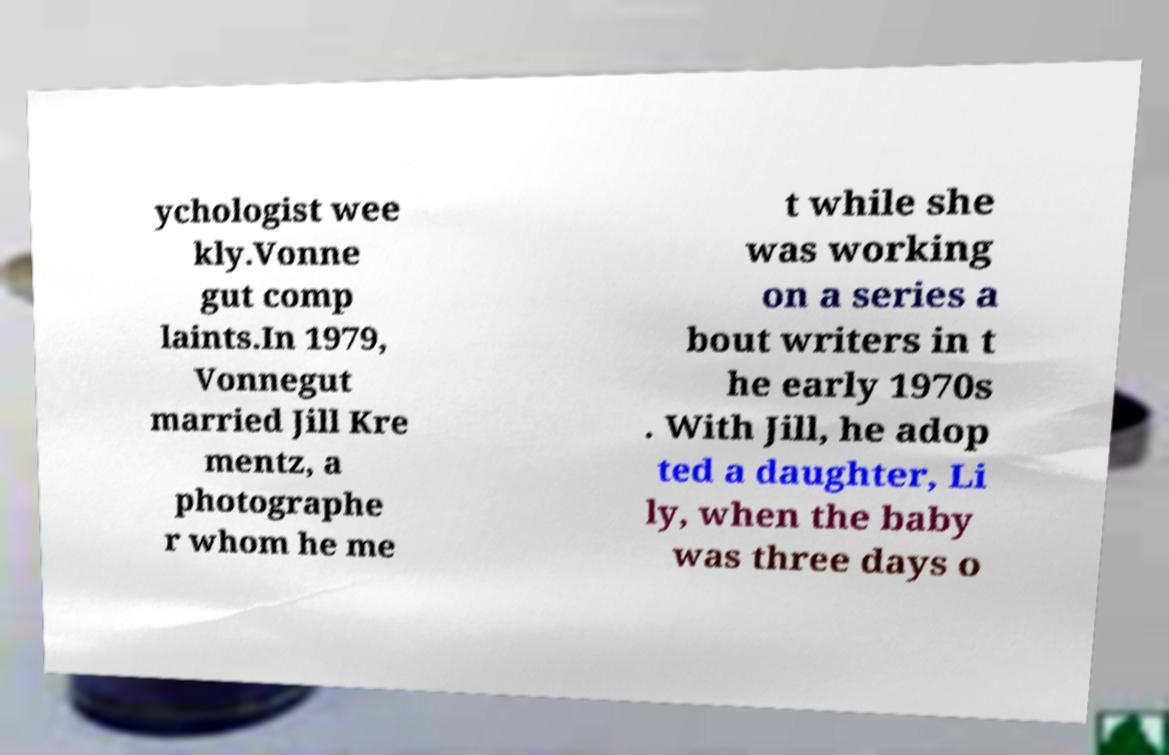Can you read and provide the text displayed in the image?This photo seems to have some interesting text. Can you extract and type it out for me? ychologist wee kly.Vonne gut comp laints.In 1979, Vonnegut married Jill Kre mentz, a photographe r whom he me t while she was working on a series a bout writers in t he early 1970s . With Jill, he adop ted a daughter, Li ly, when the baby was three days o 